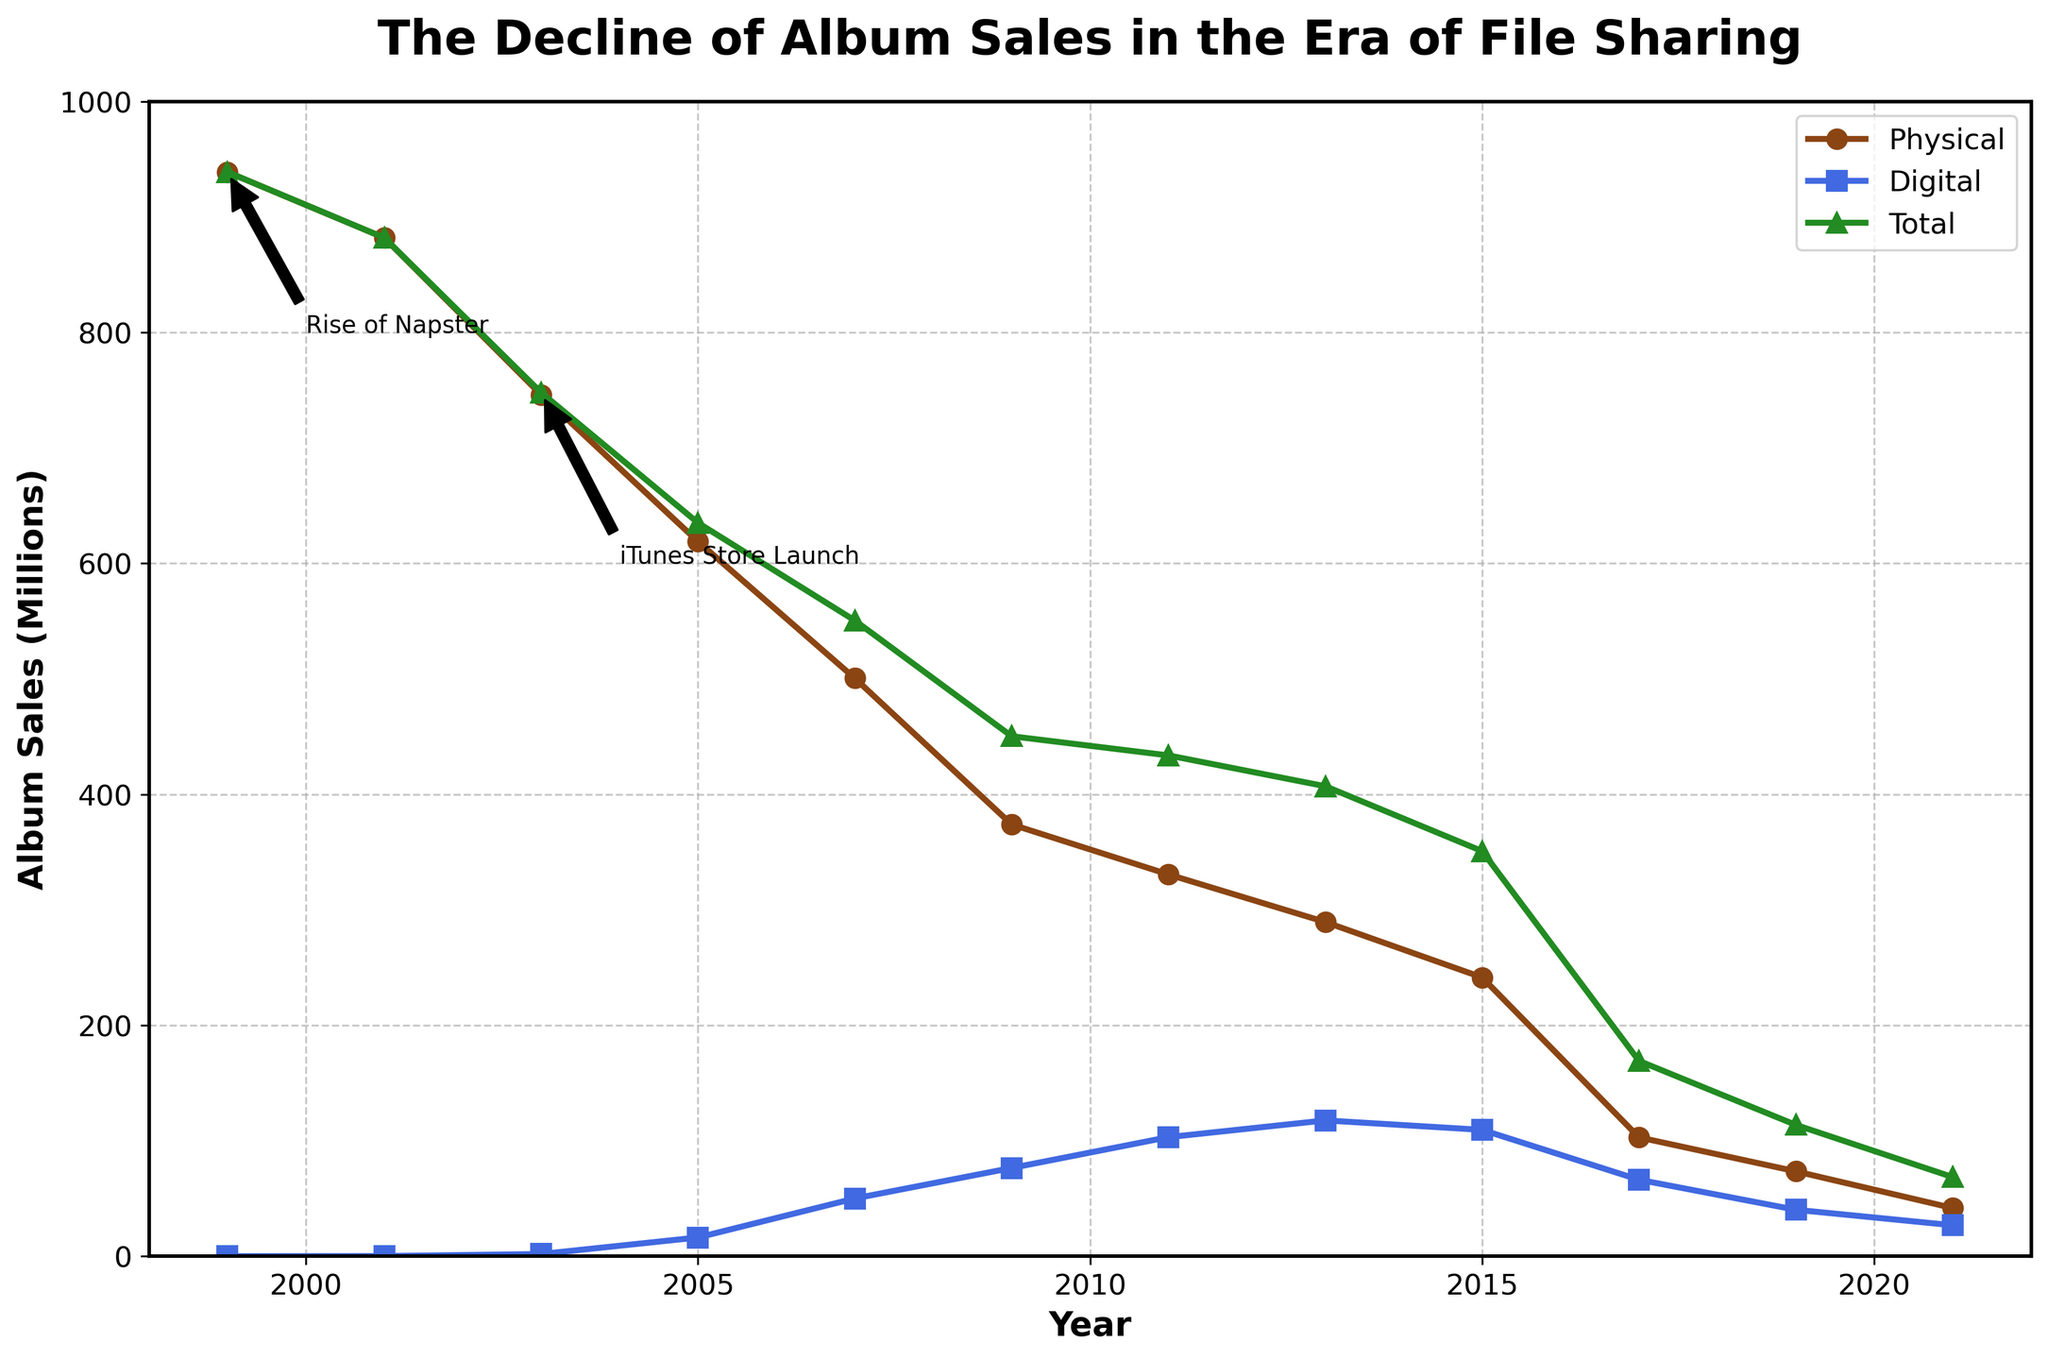What were the physical album sales before and after the rise of Napster in 1999? The graph shows physical album sales at the rise of Napster (1999), indicated by an annotation. Compare the physical sales in 1999 (938.9 million) with sales in 2001 (881.9 million).
Answer: 938.9 million before, 881.9 million after What is the difference in total album sales between the years 2007 and 2015? The total album sales in 2007 and 2015 are displayed on the graph as 550.5 million and 350.8 million respectively. The difference can be calculated: 550.5 - 350.8.
Answer: 199.7 million Which type of album sales showed a rise from 2001 to 2011, physical or digital? To determine the trend, compare the physical sales in 2001 (881.9 million) to 2011 (330.6 million) and digital sales in 2001 (0.1 million) to 2011 (103.1 million). Physical sales decreased while digital sales increased.
Answer: Digital By how much did digital album sales peak, and in which year? The peak digital album sales can be observed as the highest point on the blue line. The peak value and year are shown as 117.6 million in 2013 on the figure.
Answer: 117.6 million in 2013 What are the total album sales indicated by the green line when digital album sales were at their peak? Locate the peak digital sales in 2013 (117.6 million), and refer to the total album sales for the same year on the graph represented by the green line, which is 407.0 million.
Answer: 407.0 million What was the trend in total album sales from 2013 to 2021? Observe the steepness and direction of the green line from 2013 (407.0 million) to 2021 (68.5 million). The line shows a continual decline over the years.
Answer: Declining Which year had approximately the same level of physical album sales as total album sales in 2017? The total album sales in 2017 are 169.1 million. Check the physical sales around 169.1 million, and find that in 2005, physical album sales were 618.9 million, which does not align. The closest match around this range seems absent as physical sales consistently decrease.
Answer: None, no matching year How did digital album sales change at the launch of the iTunes Store compared to its previous data point? Examine the annotation indicating the iTunes Store launch (2003) and compare it with the prior data point (2001). The digital sales increased from 0.1 million (2001) to 1.9 million (2003).
Answer: Increased by 1.8 million By which year did digital album sales surpass 50 million? Follow the blue line for digital sales and identify the point where it crosses above 50 million. This occurs in 2007.
Answer: 2007 How did total and physical album sales compare in 2009? The graph indicates values for 2009: total album sales at 450.3 million (green line) and physical album sales at 373.9 million (brown line). Physical sales are less than total sales for 2009.
Answer: Total > Physical 